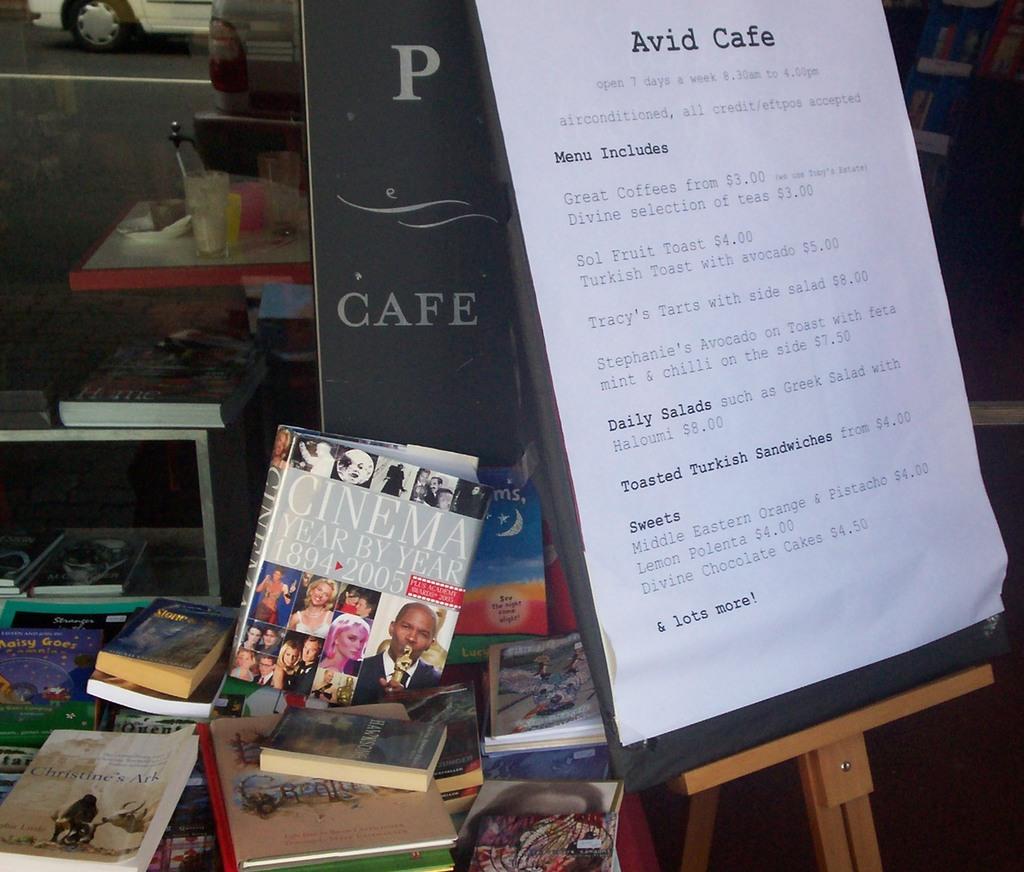What kind of sweets does this cafe have?
Keep it short and to the point. Divine chocolate cakes. What does the book say?
Offer a terse response. Cinema year by year. 